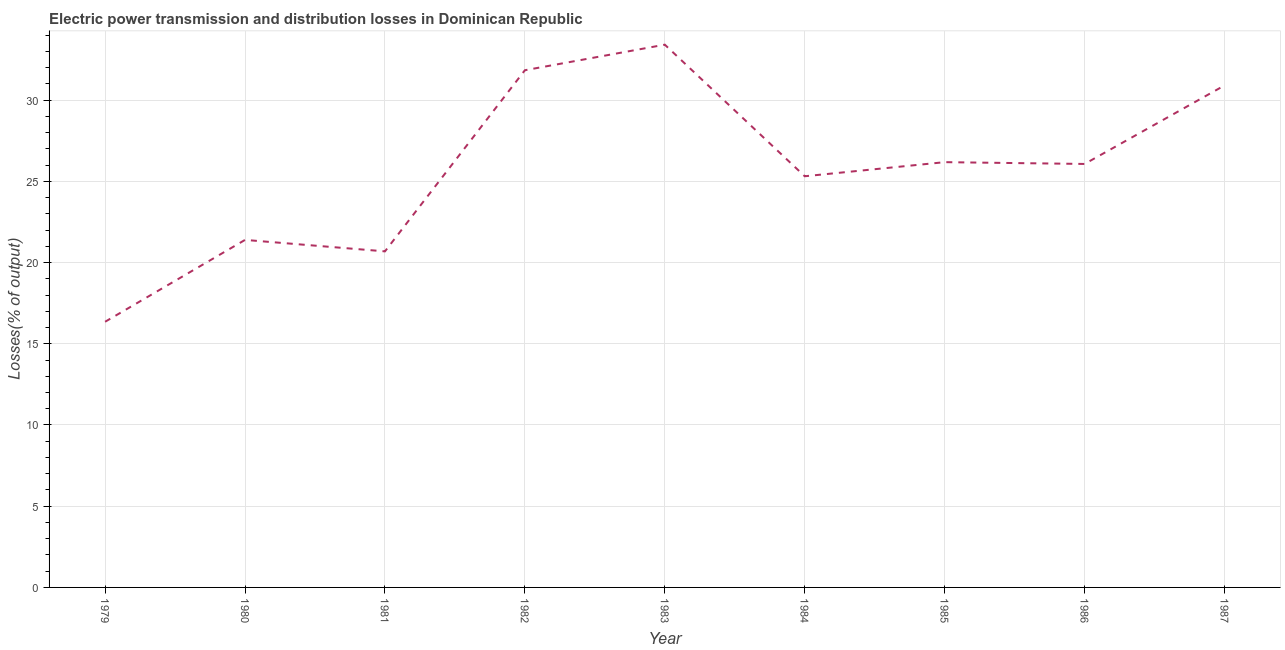What is the electric power transmission and distribution losses in 1985?
Provide a succinct answer. 26.18. Across all years, what is the maximum electric power transmission and distribution losses?
Provide a succinct answer. 33.41. Across all years, what is the minimum electric power transmission and distribution losses?
Provide a short and direct response. 16.35. In which year was the electric power transmission and distribution losses maximum?
Provide a succinct answer. 1983. In which year was the electric power transmission and distribution losses minimum?
Provide a short and direct response. 1979. What is the sum of the electric power transmission and distribution losses?
Provide a succinct answer. 232.15. What is the difference between the electric power transmission and distribution losses in 1979 and 1983?
Offer a terse response. -17.06. What is the average electric power transmission and distribution losses per year?
Your answer should be very brief. 25.79. What is the median electric power transmission and distribution losses?
Your response must be concise. 26.07. In how many years, is the electric power transmission and distribution losses greater than 17 %?
Your answer should be compact. 8. What is the ratio of the electric power transmission and distribution losses in 1980 to that in 1986?
Offer a terse response. 0.82. Is the difference between the electric power transmission and distribution losses in 1979 and 1987 greater than the difference between any two years?
Provide a succinct answer. No. What is the difference between the highest and the second highest electric power transmission and distribution losses?
Your response must be concise. 1.57. Is the sum of the electric power transmission and distribution losses in 1982 and 1984 greater than the maximum electric power transmission and distribution losses across all years?
Offer a terse response. Yes. What is the difference between the highest and the lowest electric power transmission and distribution losses?
Your answer should be very brief. 17.06. In how many years, is the electric power transmission and distribution losses greater than the average electric power transmission and distribution losses taken over all years?
Your response must be concise. 5. How many lines are there?
Offer a very short reply. 1. How many years are there in the graph?
Provide a short and direct response. 9. What is the difference between two consecutive major ticks on the Y-axis?
Your response must be concise. 5. Are the values on the major ticks of Y-axis written in scientific E-notation?
Ensure brevity in your answer.  No. Does the graph contain any zero values?
Your answer should be very brief. No. What is the title of the graph?
Your answer should be very brief. Electric power transmission and distribution losses in Dominican Republic. What is the label or title of the Y-axis?
Offer a terse response. Losses(% of output). What is the Losses(% of output) of 1979?
Make the answer very short. 16.35. What is the Losses(% of output) in 1980?
Make the answer very short. 21.39. What is the Losses(% of output) in 1981?
Keep it short and to the point. 20.69. What is the Losses(% of output) of 1982?
Provide a succinct answer. 31.84. What is the Losses(% of output) of 1983?
Ensure brevity in your answer.  33.41. What is the Losses(% of output) in 1984?
Provide a succinct answer. 25.31. What is the Losses(% of output) of 1985?
Provide a succinct answer. 26.18. What is the Losses(% of output) of 1986?
Provide a short and direct response. 26.07. What is the Losses(% of output) of 1987?
Your answer should be very brief. 30.9. What is the difference between the Losses(% of output) in 1979 and 1980?
Your response must be concise. -5.04. What is the difference between the Losses(% of output) in 1979 and 1981?
Give a very brief answer. -4.33. What is the difference between the Losses(% of output) in 1979 and 1982?
Provide a succinct answer. -15.48. What is the difference between the Losses(% of output) in 1979 and 1983?
Give a very brief answer. -17.06. What is the difference between the Losses(% of output) in 1979 and 1984?
Offer a terse response. -8.96. What is the difference between the Losses(% of output) in 1979 and 1985?
Keep it short and to the point. -9.83. What is the difference between the Losses(% of output) in 1979 and 1986?
Offer a terse response. -9.71. What is the difference between the Losses(% of output) in 1979 and 1987?
Make the answer very short. -14.55. What is the difference between the Losses(% of output) in 1980 and 1981?
Give a very brief answer. 0.71. What is the difference between the Losses(% of output) in 1980 and 1982?
Make the answer very short. -10.44. What is the difference between the Losses(% of output) in 1980 and 1983?
Your answer should be very brief. -12.02. What is the difference between the Losses(% of output) in 1980 and 1984?
Provide a short and direct response. -3.92. What is the difference between the Losses(% of output) in 1980 and 1985?
Keep it short and to the point. -4.79. What is the difference between the Losses(% of output) in 1980 and 1986?
Provide a short and direct response. -4.68. What is the difference between the Losses(% of output) in 1980 and 1987?
Your answer should be very brief. -9.51. What is the difference between the Losses(% of output) in 1981 and 1982?
Offer a terse response. -11.15. What is the difference between the Losses(% of output) in 1981 and 1983?
Your response must be concise. -12.72. What is the difference between the Losses(% of output) in 1981 and 1984?
Your response must be concise. -4.62. What is the difference between the Losses(% of output) in 1981 and 1985?
Your response must be concise. -5.49. What is the difference between the Losses(% of output) in 1981 and 1986?
Your answer should be compact. -5.38. What is the difference between the Losses(% of output) in 1981 and 1987?
Provide a succinct answer. -10.22. What is the difference between the Losses(% of output) in 1982 and 1983?
Make the answer very short. -1.57. What is the difference between the Losses(% of output) in 1982 and 1984?
Offer a terse response. 6.53. What is the difference between the Losses(% of output) in 1982 and 1985?
Your answer should be compact. 5.66. What is the difference between the Losses(% of output) in 1982 and 1986?
Provide a short and direct response. 5.77. What is the difference between the Losses(% of output) in 1982 and 1987?
Offer a terse response. 0.94. What is the difference between the Losses(% of output) in 1983 and 1984?
Make the answer very short. 8.1. What is the difference between the Losses(% of output) in 1983 and 1985?
Offer a very short reply. 7.23. What is the difference between the Losses(% of output) in 1983 and 1986?
Your answer should be compact. 7.34. What is the difference between the Losses(% of output) in 1983 and 1987?
Make the answer very short. 2.51. What is the difference between the Losses(% of output) in 1984 and 1985?
Provide a short and direct response. -0.87. What is the difference between the Losses(% of output) in 1984 and 1986?
Offer a terse response. -0.76. What is the difference between the Losses(% of output) in 1984 and 1987?
Your response must be concise. -5.59. What is the difference between the Losses(% of output) in 1985 and 1986?
Keep it short and to the point. 0.11. What is the difference between the Losses(% of output) in 1985 and 1987?
Offer a terse response. -4.72. What is the difference between the Losses(% of output) in 1986 and 1987?
Keep it short and to the point. -4.83. What is the ratio of the Losses(% of output) in 1979 to that in 1980?
Your answer should be compact. 0.76. What is the ratio of the Losses(% of output) in 1979 to that in 1981?
Make the answer very short. 0.79. What is the ratio of the Losses(% of output) in 1979 to that in 1982?
Make the answer very short. 0.51. What is the ratio of the Losses(% of output) in 1979 to that in 1983?
Provide a succinct answer. 0.49. What is the ratio of the Losses(% of output) in 1979 to that in 1984?
Offer a terse response. 0.65. What is the ratio of the Losses(% of output) in 1979 to that in 1985?
Your answer should be compact. 0.62. What is the ratio of the Losses(% of output) in 1979 to that in 1986?
Keep it short and to the point. 0.63. What is the ratio of the Losses(% of output) in 1979 to that in 1987?
Provide a short and direct response. 0.53. What is the ratio of the Losses(% of output) in 1980 to that in 1981?
Make the answer very short. 1.03. What is the ratio of the Losses(% of output) in 1980 to that in 1982?
Offer a terse response. 0.67. What is the ratio of the Losses(% of output) in 1980 to that in 1983?
Provide a short and direct response. 0.64. What is the ratio of the Losses(% of output) in 1980 to that in 1984?
Make the answer very short. 0.84. What is the ratio of the Losses(% of output) in 1980 to that in 1985?
Keep it short and to the point. 0.82. What is the ratio of the Losses(% of output) in 1980 to that in 1986?
Provide a succinct answer. 0.82. What is the ratio of the Losses(% of output) in 1980 to that in 1987?
Keep it short and to the point. 0.69. What is the ratio of the Losses(% of output) in 1981 to that in 1982?
Your answer should be very brief. 0.65. What is the ratio of the Losses(% of output) in 1981 to that in 1983?
Offer a terse response. 0.62. What is the ratio of the Losses(% of output) in 1981 to that in 1984?
Provide a succinct answer. 0.82. What is the ratio of the Losses(% of output) in 1981 to that in 1985?
Your response must be concise. 0.79. What is the ratio of the Losses(% of output) in 1981 to that in 1986?
Keep it short and to the point. 0.79. What is the ratio of the Losses(% of output) in 1981 to that in 1987?
Keep it short and to the point. 0.67. What is the ratio of the Losses(% of output) in 1982 to that in 1983?
Give a very brief answer. 0.95. What is the ratio of the Losses(% of output) in 1982 to that in 1984?
Make the answer very short. 1.26. What is the ratio of the Losses(% of output) in 1982 to that in 1985?
Offer a very short reply. 1.22. What is the ratio of the Losses(% of output) in 1982 to that in 1986?
Your response must be concise. 1.22. What is the ratio of the Losses(% of output) in 1982 to that in 1987?
Your answer should be compact. 1.03. What is the ratio of the Losses(% of output) in 1983 to that in 1984?
Your answer should be very brief. 1.32. What is the ratio of the Losses(% of output) in 1983 to that in 1985?
Provide a succinct answer. 1.28. What is the ratio of the Losses(% of output) in 1983 to that in 1986?
Give a very brief answer. 1.28. What is the ratio of the Losses(% of output) in 1983 to that in 1987?
Provide a short and direct response. 1.08. What is the ratio of the Losses(% of output) in 1984 to that in 1987?
Keep it short and to the point. 0.82. What is the ratio of the Losses(% of output) in 1985 to that in 1987?
Offer a very short reply. 0.85. What is the ratio of the Losses(% of output) in 1986 to that in 1987?
Give a very brief answer. 0.84. 